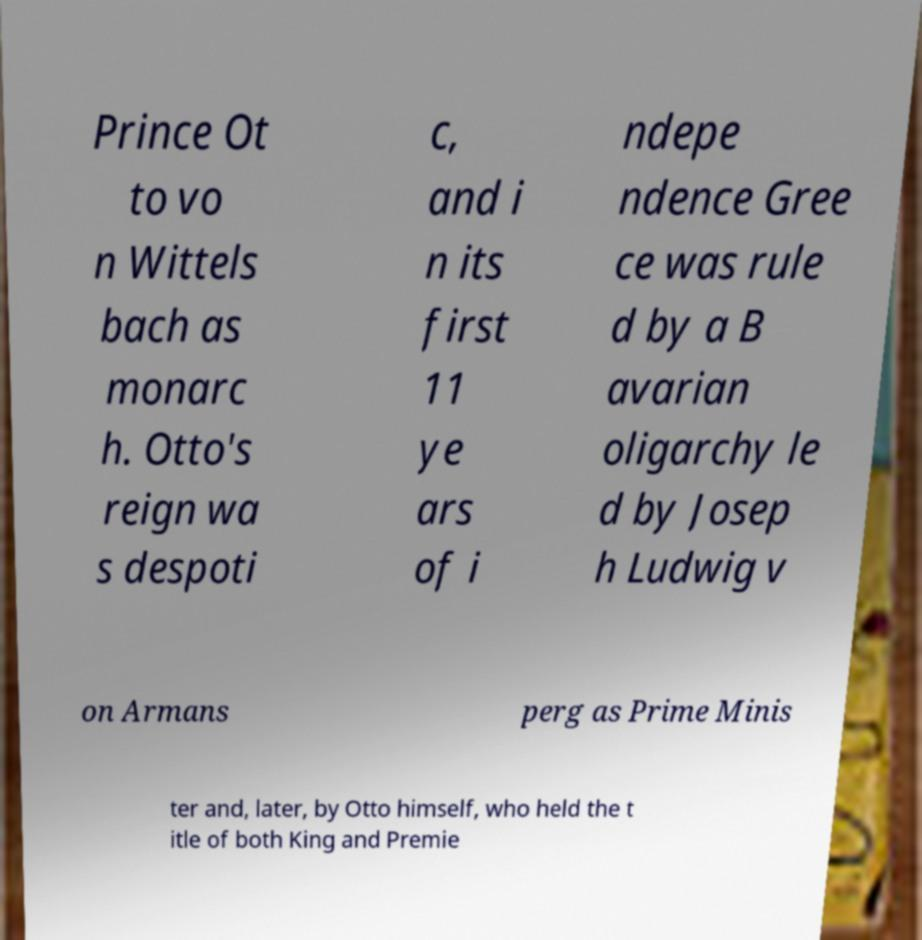Please read and relay the text visible in this image. What does it say? Prince Ot to vo n Wittels bach as monarc h. Otto's reign wa s despoti c, and i n its first 11 ye ars of i ndepe ndence Gree ce was rule d by a B avarian oligarchy le d by Josep h Ludwig v on Armans perg as Prime Minis ter and, later, by Otto himself, who held the t itle of both King and Premie 